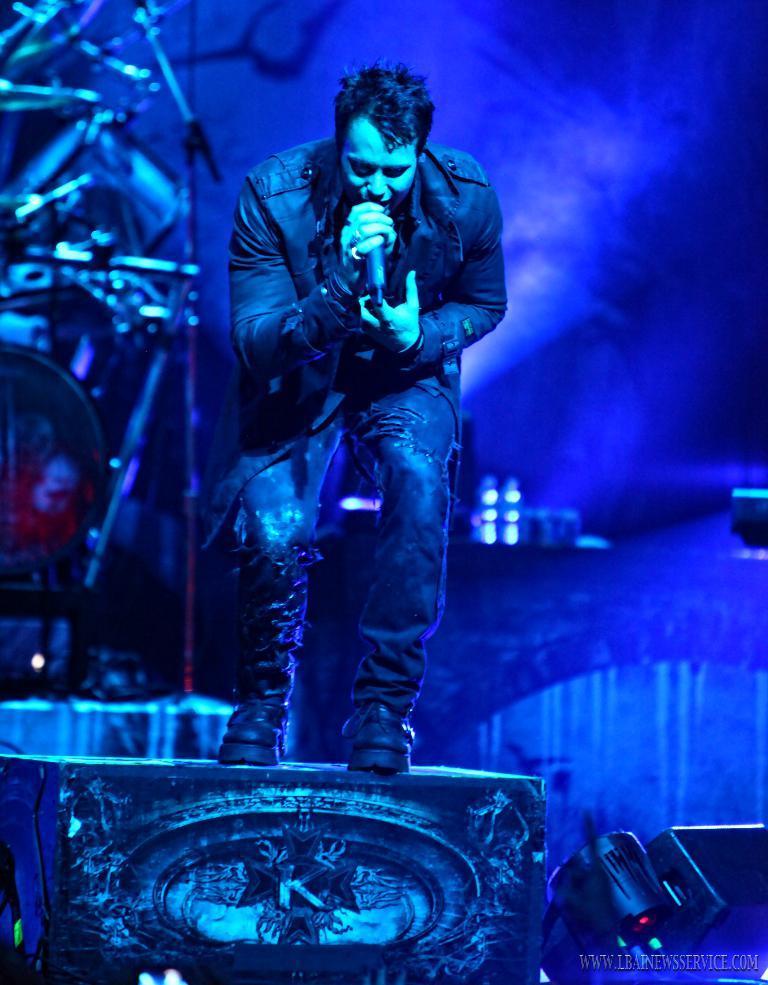Describe this image in one or two sentences. In this picture we can see a person holding a microphone and standing on a block. On this block, we can see the letter K and some art. There is a black object and some text in the bottom right. There is a drum, musical instruments and lights in the background. 